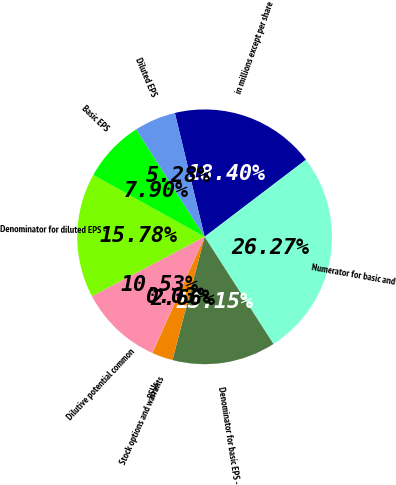Convert chart to OTSL. <chart><loc_0><loc_0><loc_500><loc_500><pie_chart><fcel>in millions except per share<fcel>Numerator for basic and<fcel>Denominator for basic EPS -<fcel>RSUs<fcel>Stock options and warrants<fcel>Dilutive potential common<fcel>Denominator for diluted EPS -<fcel>Basic EPS<fcel>Diluted EPS<nl><fcel>18.4%<fcel>26.27%<fcel>13.15%<fcel>2.66%<fcel>0.03%<fcel>10.53%<fcel>15.78%<fcel>7.9%<fcel>5.28%<nl></chart> 